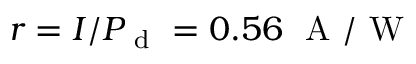<formula> <loc_0><loc_0><loc_500><loc_500>r = I / P _ { d } = 0 . 5 6 A / W</formula> 